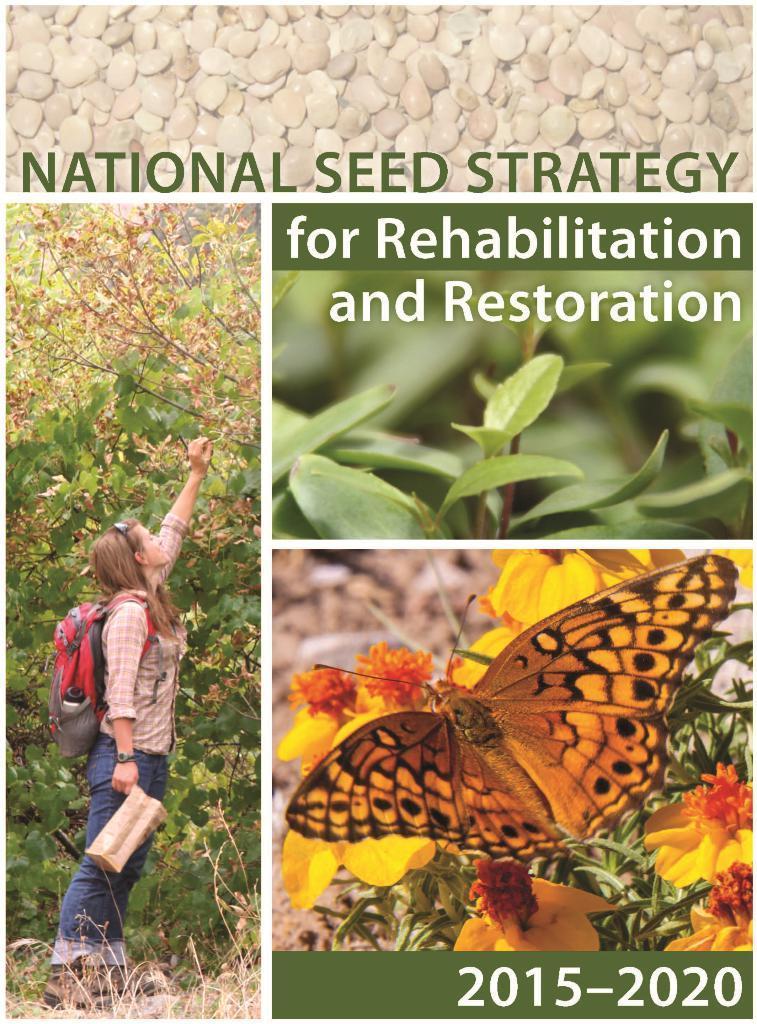Please provide a concise description of this image. In this image we can see the collage of woman standing on the ground, plants and a butter fly on the plants. 